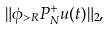<formula> <loc_0><loc_0><loc_500><loc_500>\| \phi _ { > R } P _ { N } ^ { + } u ( t ) \| _ { 2 } ,</formula> 